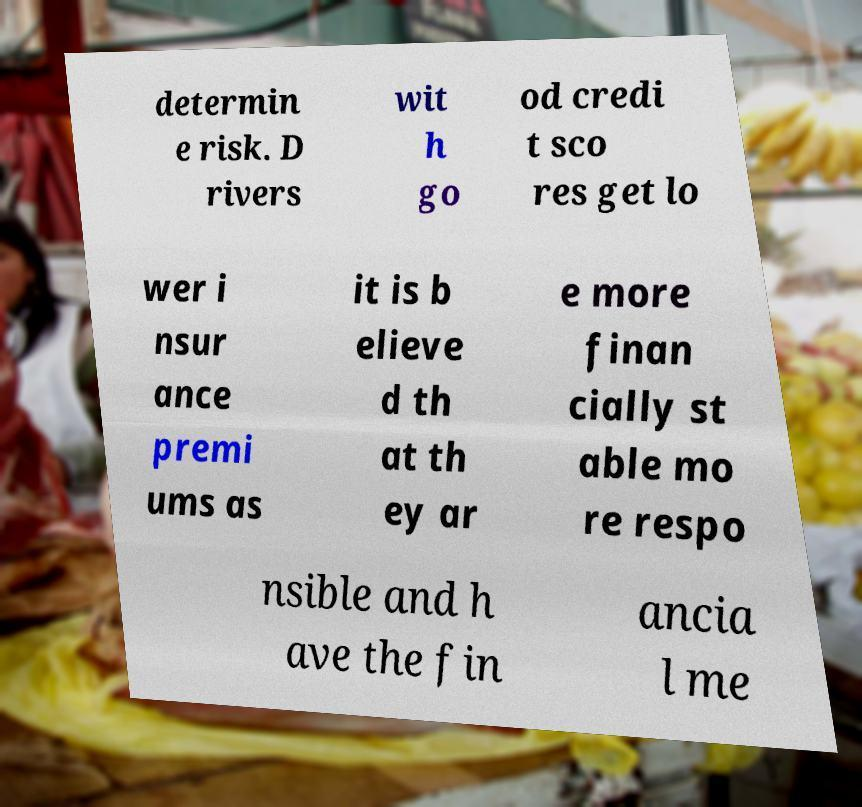Could you extract and type out the text from this image? determin e risk. D rivers wit h go od credi t sco res get lo wer i nsur ance premi ums as it is b elieve d th at th ey ar e more finan cially st able mo re respo nsible and h ave the fin ancia l me 